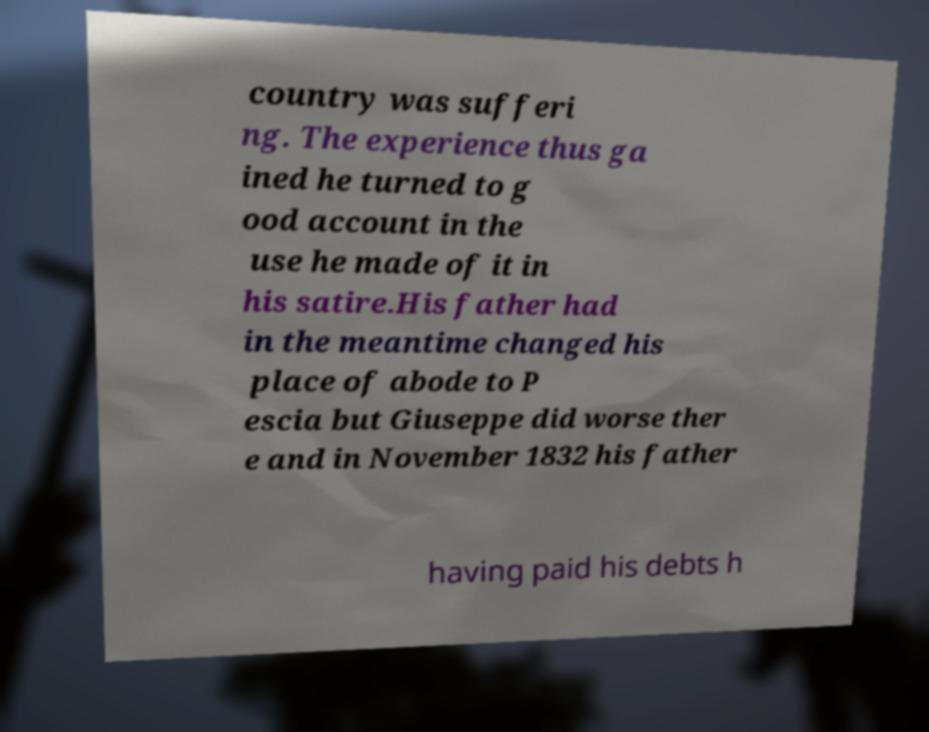For documentation purposes, I need the text within this image transcribed. Could you provide that? country was sufferi ng. The experience thus ga ined he turned to g ood account in the use he made of it in his satire.His father had in the meantime changed his place of abode to P escia but Giuseppe did worse ther e and in November 1832 his father having paid his debts h 